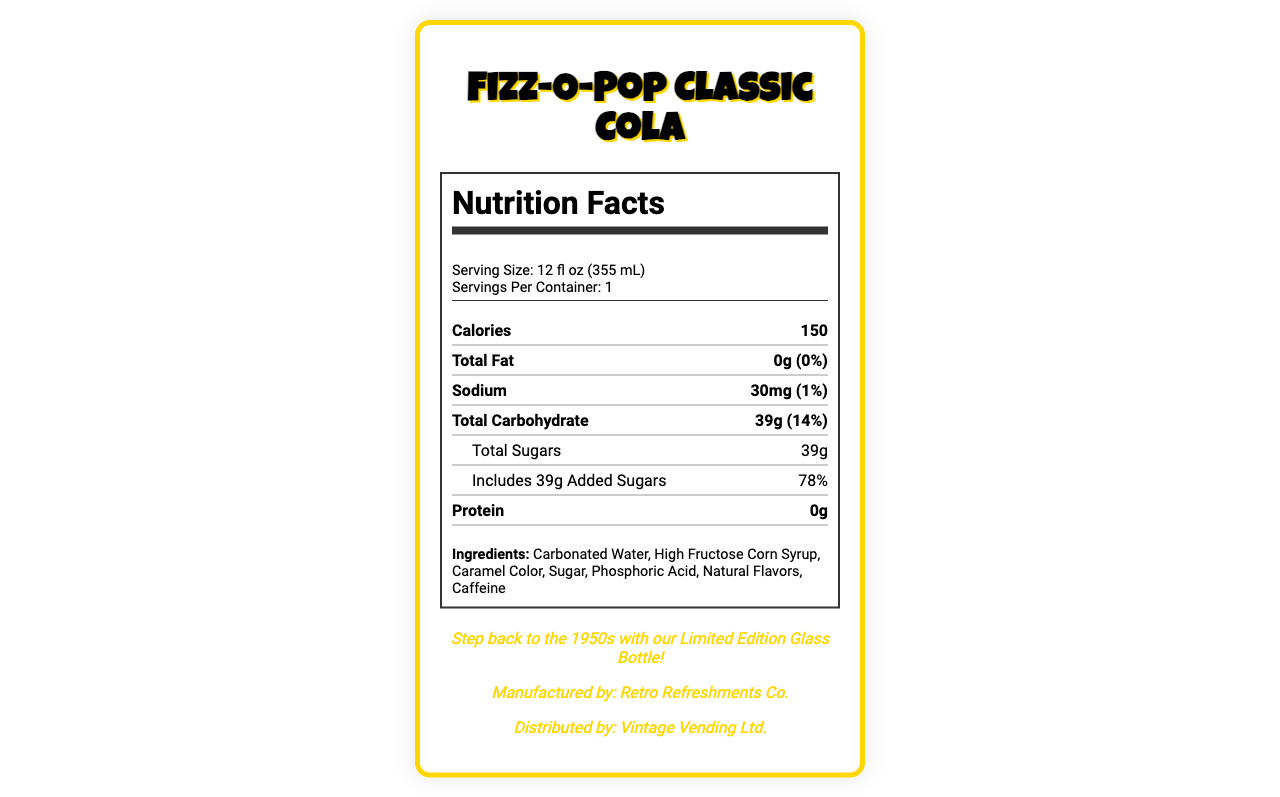what is the serving size? The serving size is mentioned at the beginning of the nutrition label.
Answer: 12 fl oz (355 mL) how many calories are in one serving? The calories per serving are clearly listed under the main nutrient section.
Answer: 150 what is the total fat content? The total fat content and its daily value percentage are specified in the main nutrient section.
Answer: 0g (0%) how much sodium is in one serving? The sodium content and its daily value percentage are mentioned in the main nutrient section.
Answer: 30mg (1%) what is the amount of total carbohydrate? The total carbohydrate content and its daily value percentage are provided in the main nutrient section.
Answer: 39g (14%) what percentage of daily value is the added sugars? The daily value percentage for added sugars is listed under the sub-nutrient section.
Answer: 78% what are the ingredients in the Fizz-O-Pop Classic Cola? The ingredients are listed near the bottom of the nutrition label.
Answer: Carbonated Water, High Fructose Corn Syrup, Caramel Color, Sugar, Phosphoric Acid, Natural Flavors, Caffeine what colors are used in the packaging design? A. Red, White, Blue B. Cherry Red, Cream, Gold C. Green, Yellow, Orange The packaging design elements specify the colors as Cherry Red, Cream, and Gold.
Answer: B which era does the Fizz-O-Pop Classic Cola aim to represent? A. 1920s B. 1950s C. 1980s D. 2000s The vintage appeal section mentions that it aims to represent the 1950s.
Answer: B what is the daily value percentage of protein? There is no protein in this drink, so the daily value percentage is 0%.
Answer: 0% is the Fizz-O-Pop Classic Cola high in vitamins or minerals? The vitamin C, calcium, iron, and potassium contents all have a 0% daily value, indicating that it is not high in any vitamins or minerals.
Answer: No describe the main idea of the document The document includes product name, serving size, nutrient breakdown, ingredients, allergen info, and packaging design elements, giving an overall picture of the product.
Answer: The document is a nutrition facts label for Fizz-O-Pop Classic Cola, providing detailed nutrient information, ingredients, and design elements reflecting a 1950s vintage appeal. is this product organic? The document doesn’t provide any information on whether the product is organic or not.
Answer: Not enough information who is the manufacturer of the Fizz-O-Pop Classic Cola? The manufacturer's name is given in the vintage appeal section near the end of the document.
Answer: Retro Refreshments Co. 